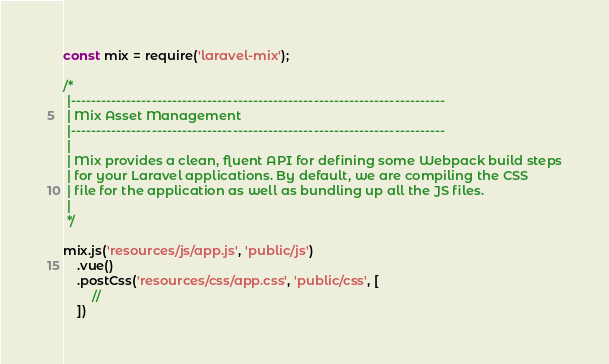<code> <loc_0><loc_0><loc_500><loc_500><_JavaScript_>const mix = require('laravel-mix');

/*
 |--------------------------------------------------------------------------
 | Mix Asset Management
 |--------------------------------------------------------------------------
 |
 | Mix provides a clean, fluent API for defining some Webpack build steps
 | for your Laravel applications. By default, we are compiling the CSS
 | file for the application as well as bundling up all the JS files.
 |
 */

mix.js('resources/js/app.js', 'public/js')
    .vue()
    .postCss('resources/css/app.css', 'public/css', [
        //
    ])
</code> 